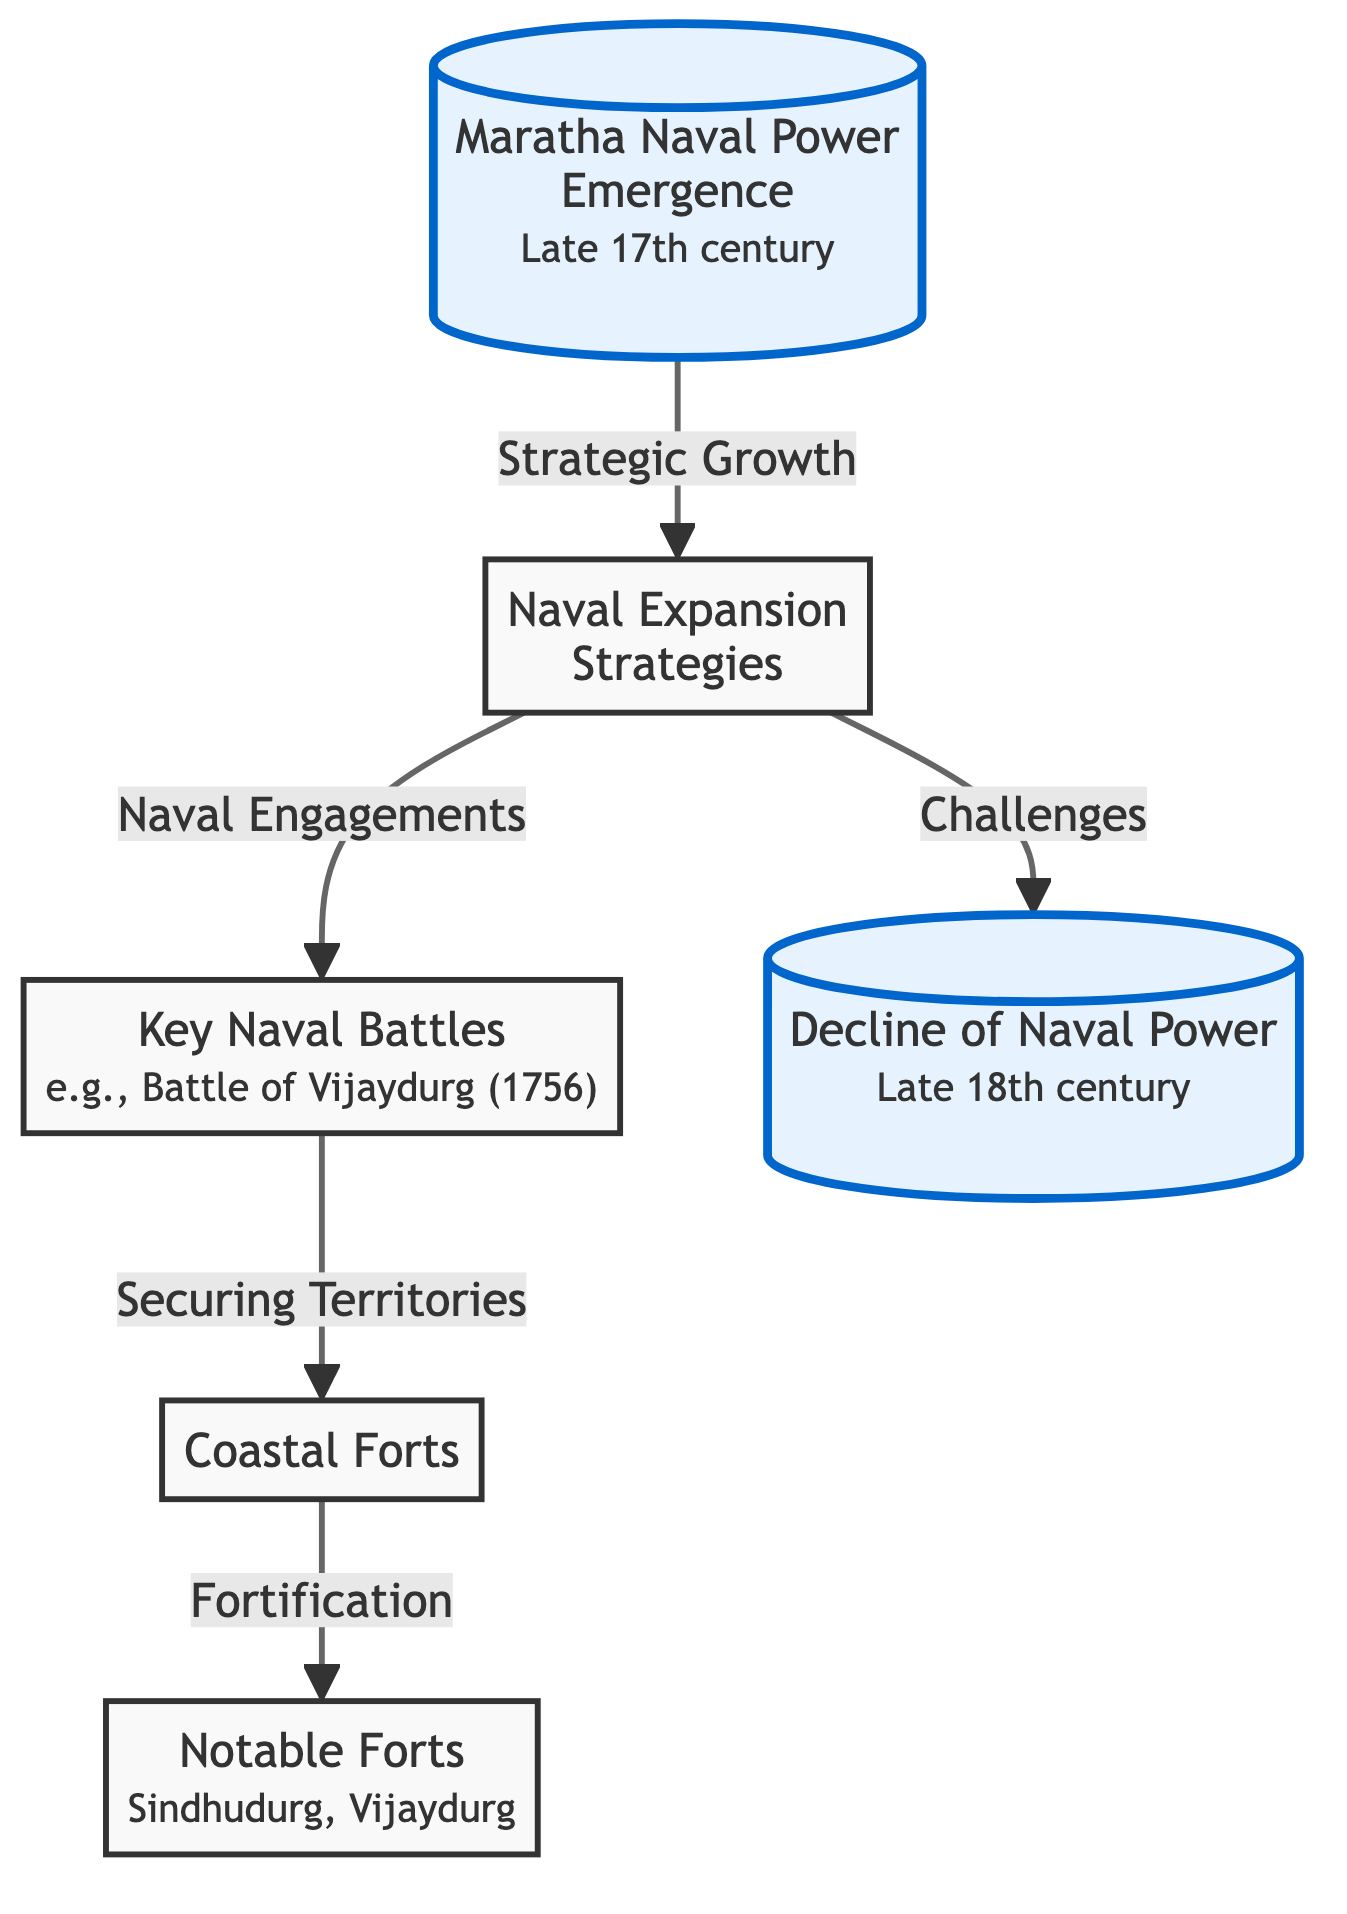What is the starting point of the diagram? The starting point of the diagram is labeled "Maratha Naval Power Emergence." It indicates the late 17th century as the time when this emergence began.
Answer: Maratha Naval Power Emergence What leads to "Naval Expansion Strategies"? The relationship arrow indicates that "Strategic Growth" leads to "Naval Expansion Strategies." This suggests that strategic growth was a crucial factor in the expansion of naval activities.
Answer: Strategic Growth How many notable forts are mentioned in the diagram? The diagram includes a note under "Notable Forts" that specifically lists two forts: Sindhudurg and Vijaydurg. Therefore, there are two notable forts mentioned.
Answer: 2 Which event is associated with "Key Naval Battles"? The diagram specifies a key event associated with "Key Naval Battles," which is the "Battle of Vijaydurg (1756)." This battle exemplifies the significant naval engagements by the Marathas.
Answer: Battle of Vijaydurg (1756) What connects "Naval Expansion Strategies" to "Decline of Naval Power"? The connection drawn indicates that "Challenges" faced during the naval expansion strategies ultimately led to the "Decline of Naval Power." This shows a cause-and-effect relationship in the diagram.
Answer: Challenges What is the significance of "Fortification" in the context of coastal forts? The diagram highlights "Fortification" as a process linked to "Coastal Forts," implying that it played a significant role in strengthening these coastal defenses.
Answer: Fortification Which two categories are emphasized in the diagram? The diagram provides emphasis on the beginning and the end of the timeline, which includes "Maratha Naval Power Emergence" and "Decline of Naval Power." These nodes are visually distinct, signaling their importance.
Answer: Maratha Naval Power Emergence, Decline of Naval Power What type of diagram is this? The diagram is a flowchart that depicts the evolution of Maratha naval expeditions and coastal forts, showing different stages and relationships in a structured format.
Answer: flowchart 